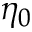<formula> <loc_0><loc_0><loc_500><loc_500>\eta _ { 0 }</formula> 